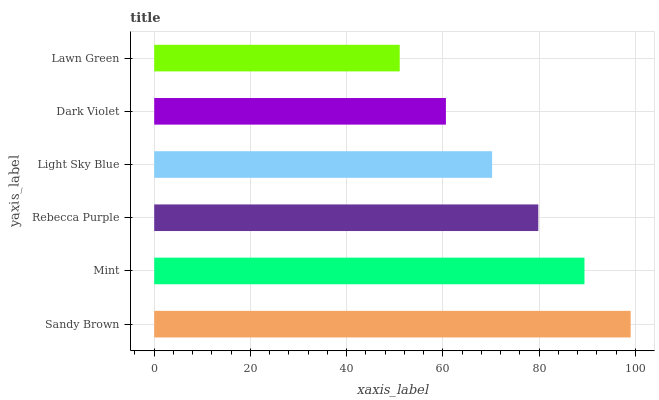Is Lawn Green the minimum?
Answer yes or no. Yes. Is Sandy Brown the maximum?
Answer yes or no. Yes. Is Mint the minimum?
Answer yes or no. No. Is Mint the maximum?
Answer yes or no. No. Is Sandy Brown greater than Mint?
Answer yes or no. Yes. Is Mint less than Sandy Brown?
Answer yes or no. Yes. Is Mint greater than Sandy Brown?
Answer yes or no. No. Is Sandy Brown less than Mint?
Answer yes or no. No. Is Rebecca Purple the high median?
Answer yes or no. Yes. Is Light Sky Blue the low median?
Answer yes or no. Yes. Is Sandy Brown the high median?
Answer yes or no. No. Is Rebecca Purple the low median?
Answer yes or no. No. 